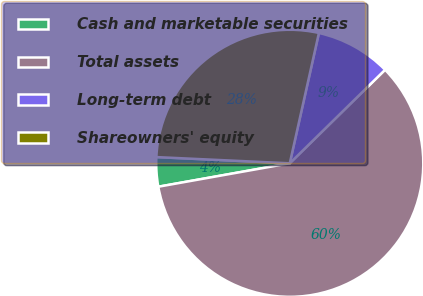Convert chart. <chart><loc_0><loc_0><loc_500><loc_500><pie_chart><fcel>Cash and marketable securities<fcel>Total assets<fcel>Long-term debt<fcel>Shareowners' equity<nl><fcel>3.55%<fcel>59.54%<fcel>9.15%<fcel>27.76%<nl></chart> 